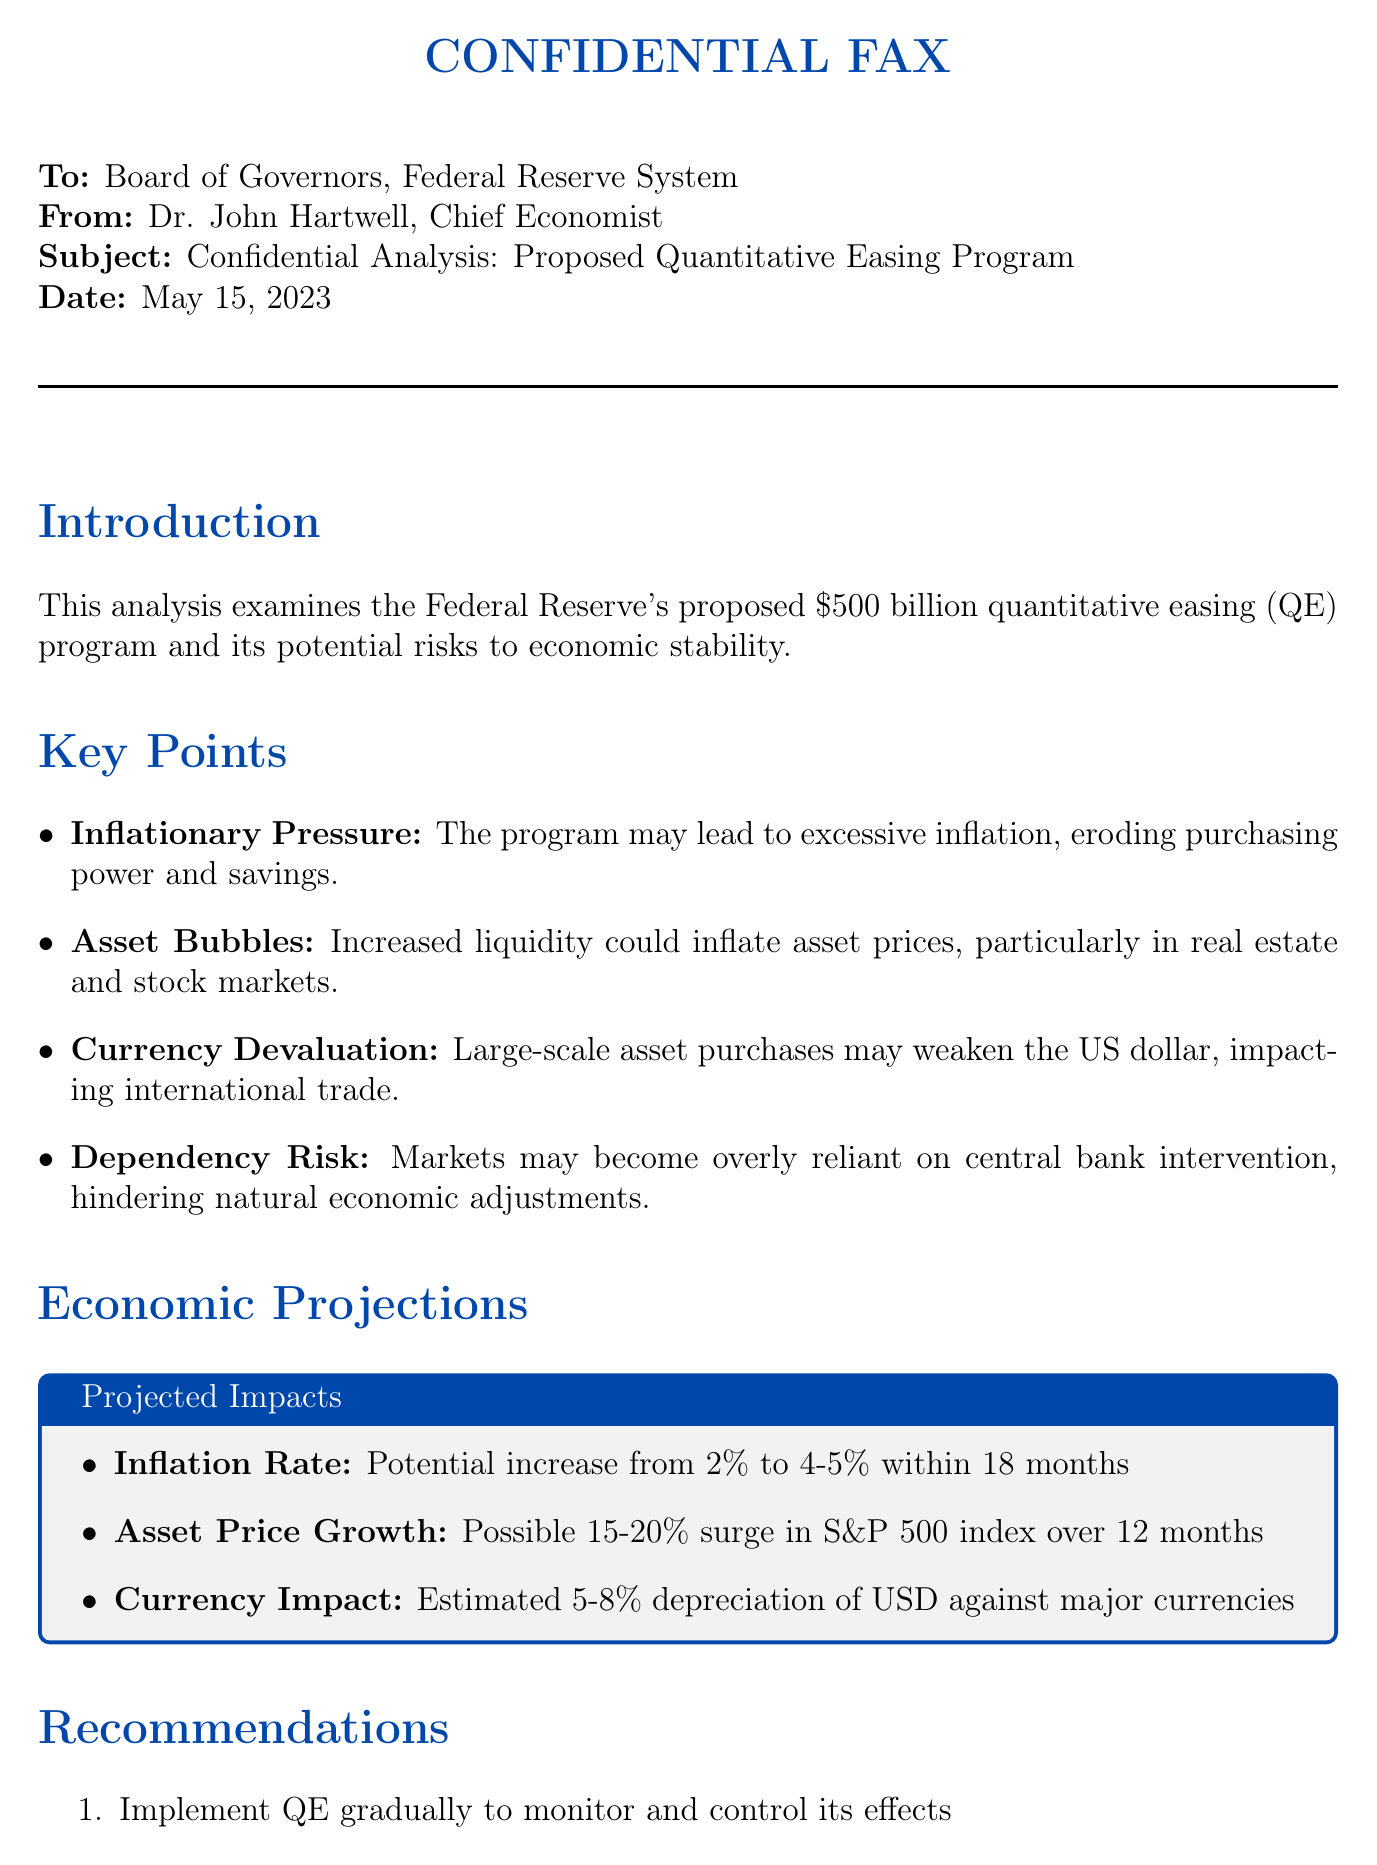what is the proposed amount for the quantitative easing program? The document states that the proposed amount for the QE program is $500 billion.
Answer: $500 billion who is the sender of the fax? The sender of the fax, as indicated in the document, is Dr. John Hartwell, Chief Economist.
Answer: Dr. John Hartwell what inflation rate increase is projected within 18 months? The projected inflation rate increase mentioned in the document is from 2% to 4-5%.
Answer: 4-5% what are the potential risks highlighted in the analysis? The analysis highlights multiple risks, including inflationary pressure, asset bubbles, currency devaluation, and dependency risk.
Answer: Inflationary pressure, asset bubbles, currency devaluation, dependency risk what is recommended to prevent market dependency on QE? The recommendation to prevent market dependency is to set clear exit strategies.
Answer: Set clear exit strategies 